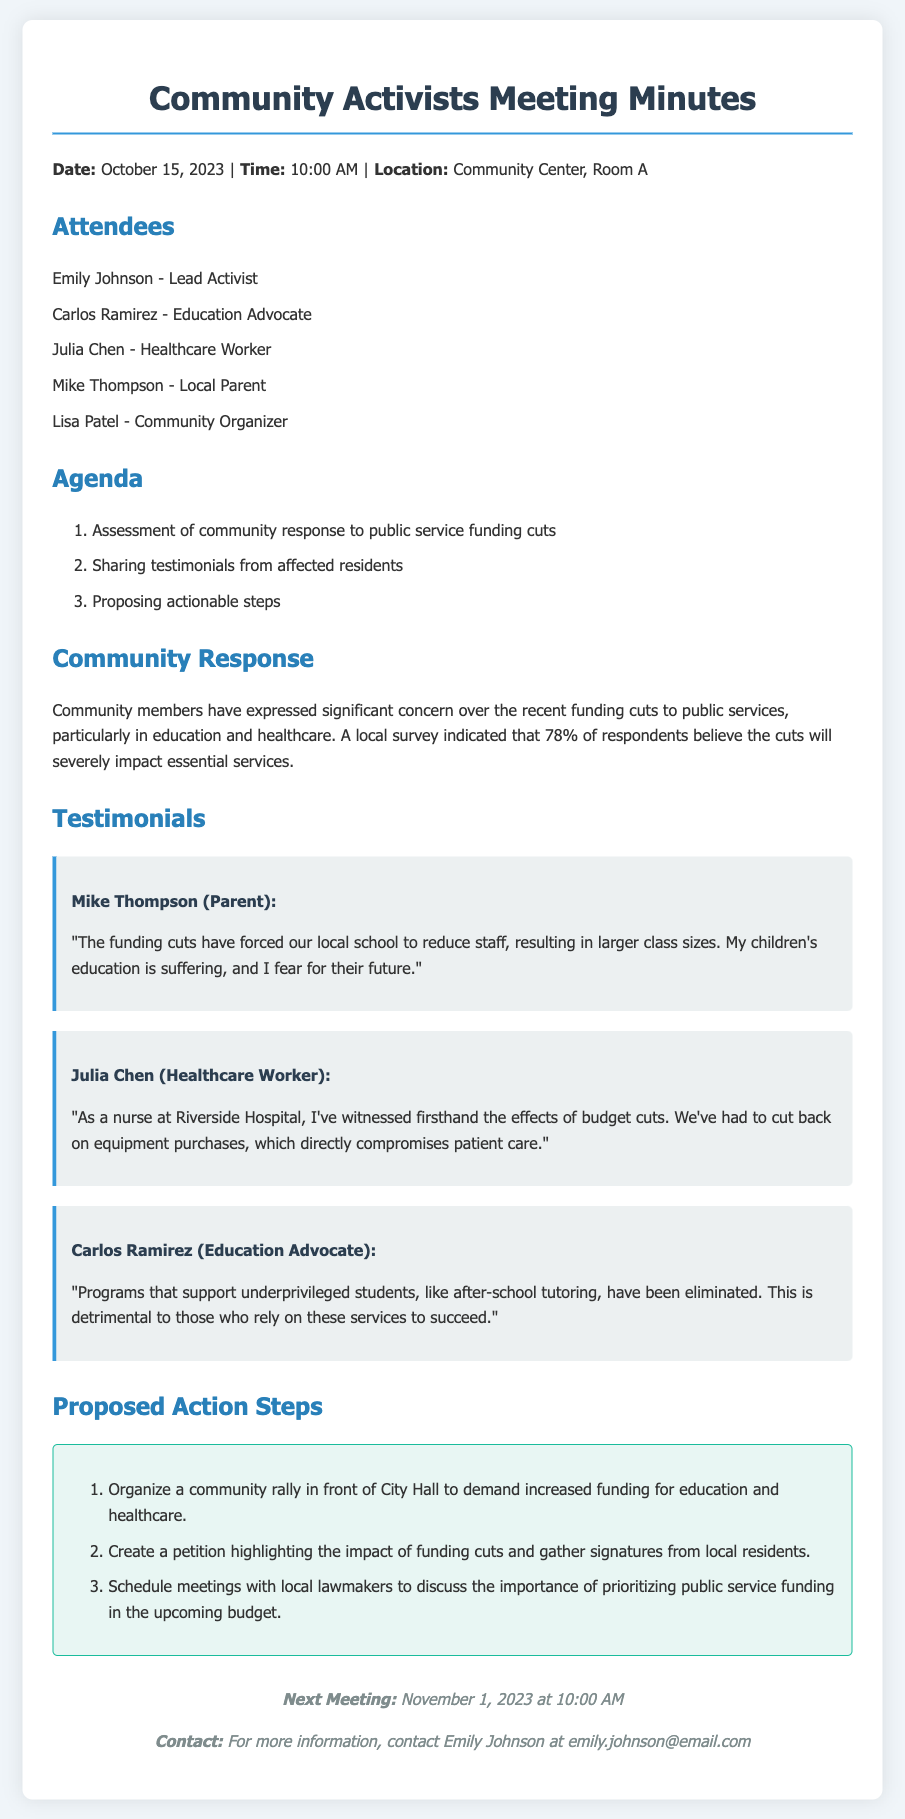what is the date of the meeting? The date of the meeting is explicitly stated in the document's header information.
Answer: October 15, 2023 who is the lead activist? The lead activist is mentioned in the list of attendees.
Answer: Emily Johnson what percentage of respondents believe the cuts will severely impact essential services? The exact percentage is provided in the community response section of the document.
Answer: 78% what action step involves local lawmakers? The action step that mentions local lawmakers indicates a scheduling of meetings to discuss funding.
Answer: Schedule meetings with local lawmakers who expressed concern about larger class sizes? The individual expressing this concern is identified in the testimonials section.
Answer: Mike Thompson which public service area is highlighted by Julia Chen? Julia Chen's testimony focuses on a specific area within public services.
Answer: Healthcare how many action steps are proposed in the document? The total number of proposed action steps can be counted in the designated section.
Answer: 3 what is the location of the meeting? The location is noted in the header information of the document.
Answer: Community Center, Room A what is the next meeting date? The date for the next meeting is provided in the closing section.
Answer: November 1, 2023 